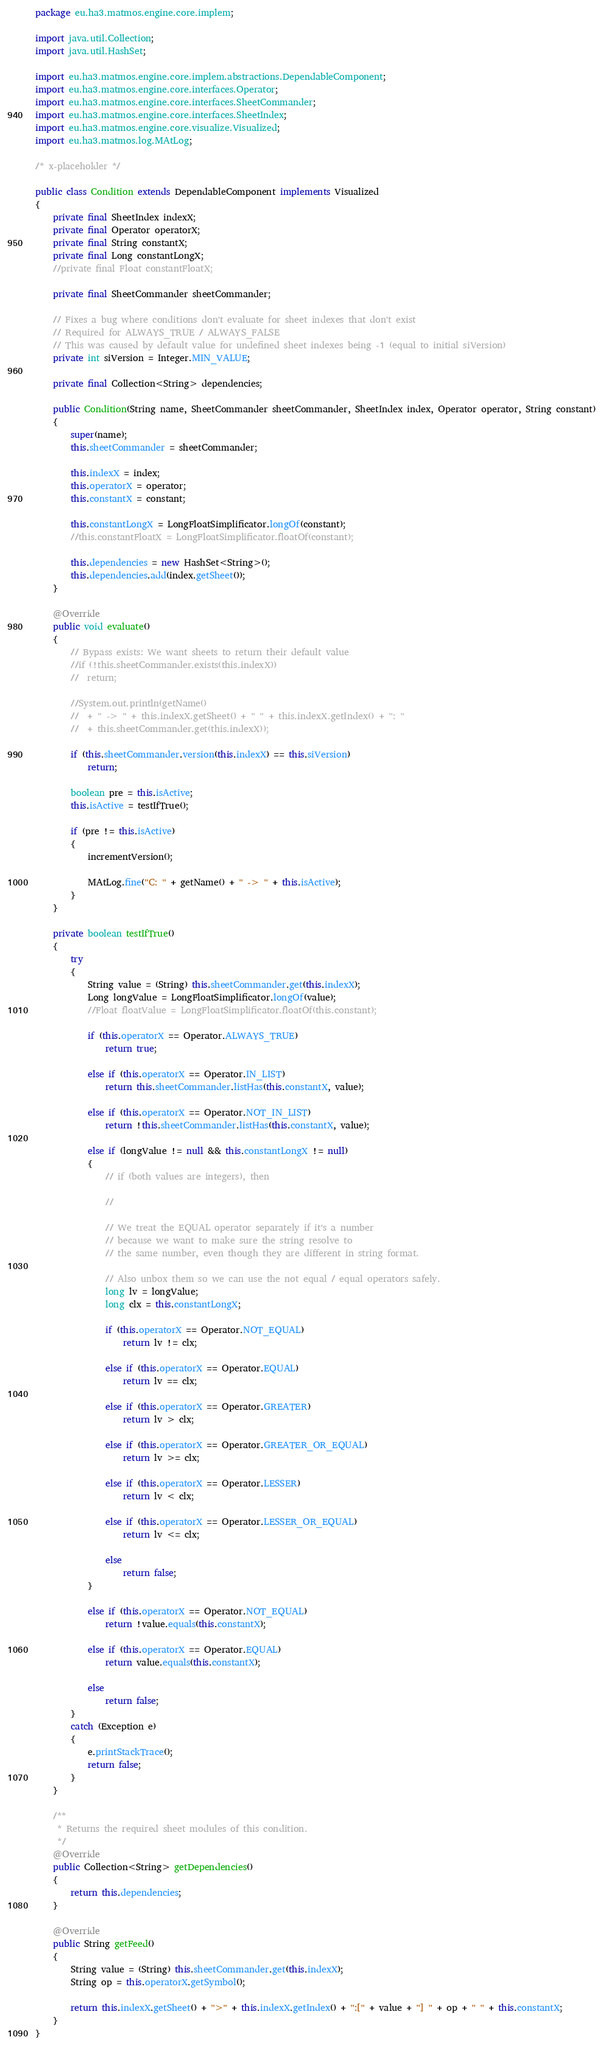<code> <loc_0><loc_0><loc_500><loc_500><_Java_>package eu.ha3.matmos.engine.core.implem;

import java.util.Collection;
import java.util.HashSet;

import eu.ha3.matmos.engine.core.implem.abstractions.DependableComponent;
import eu.ha3.matmos.engine.core.interfaces.Operator;
import eu.ha3.matmos.engine.core.interfaces.SheetCommander;
import eu.ha3.matmos.engine.core.interfaces.SheetIndex;
import eu.ha3.matmos.engine.core.visualize.Visualized;
import eu.ha3.matmos.log.MAtLog;

/* x-placeholder */

public class Condition extends DependableComponent implements Visualized
{
	private final SheetIndex indexX;
	private final Operator operatorX;
	private final String constantX;
	private final Long constantLongX;
	//private final Float constantFloatX;
	
	private final SheetCommander sheetCommander;
	
	// Fixes a bug where conditions don't evaluate for sheet indexes that don't exist
	// Required for ALWAYS_TRUE / ALWAYS_FALSE
	// This was caused by default value for undefined sheet indexes being -1 (equal to initial siVersion)
	private int siVersion = Integer.MIN_VALUE;
	
	private final Collection<String> dependencies;
	
	public Condition(String name, SheetCommander sheetCommander, SheetIndex index, Operator operator, String constant)
	{
		super(name);
		this.sheetCommander = sheetCommander;
		
		this.indexX = index;
		this.operatorX = operator;
		this.constantX = constant;
		
		this.constantLongX = LongFloatSimplificator.longOf(constant);
		//this.constantFloatX = LongFloatSimplificator.floatOf(constant);
		
		this.dependencies = new HashSet<String>();
		this.dependencies.add(index.getSheet());
	}
	
	@Override
	public void evaluate()
	{
		// Bypass exists: We want sheets to return their default value
		//if (!this.sheetCommander.exists(this.indexX))
		//	return;
		
		//System.out.println(getName()
		//	+ " -> " + this.indexX.getSheet() + " " + this.indexX.getIndex() + ": "
		//	+ this.sheetCommander.get(this.indexX));
		
		if (this.sheetCommander.version(this.indexX) == this.siVersion)
			return;
		
		boolean pre = this.isActive;
		this.isActive = testIfTrue();
		
		if (pre != this.isActive)
		{
			incrementVersion();
			
			MAtLog.fine("C: " + getName() + " -> " + this.isActive);
		}
	}
	
	private boolean testIfTrue()
	{
		try
		{
			String value = (String) this.sheetCommander.get(this.indexX);
			Long longValue = LongFloatSimplificator.longOf(value);
			//Float floatValue = LongFloatSimplificator.floatOf(this.constant);
			
			if (this.operatorX == Operator.ALWAYS_TRUE)
				return true;
			
			else if (this.operatorX == Operator.IN_LIST)
				return this.sheetCommander.listHas(this.constantX, value);
			
			else if (this.operatorX == Operator.NOT_IN_LIST)
				return !this.sheetCommander.listHas(this.constantX, value);
			
			else if (longValue != null && this.constantLongX != null)
			{
				// if (both values are integers), then
				
				//
				
				// We treat the EQUAL operator separately if it's a number
				// because we want to make sure the string resolve to
				// the same number, even though they are different in string format.
				
				// Also unbox them so we can use the not equal / equal operators safely.
				long lv = longValue;
				long clx = this.constantLongX;
				
				if (this.operatorX == Operator.NOT_EQUAL)
					return lv != clx;
				
				else if (this.operatorX == Operator.EQUAL)
					return lv == clx;
				
				else if (this.operatorX == Operator.GREATER)
					return lv > clx;
				
				else if (this.operatorX == Operator.GREATER_OR_EQUAL)
					return lv >= clx;
				
				else if (this.operatorX == Operator.LESSER)
					return lv < clx;
				
				else if (this.operatorX == Operator.LESSER_OR_EQUAL)
					return lv <= clx;
				
				else
					return false;
			}
			
			else if (this.operatorX == Operator.NOT_EQUAL)
				return !value.equals(this.constantX);
			
			else if (this.operatorX == Operator.EQUAL)
				return value.equals(this.constantX);
			
			else
				return false;
		}
		catch (Exception e)
		{
			e.printStackTrace();
			return false;
		}
	}
	
	/**
	 * Returns the required sheet modules of this condition.
	 */
	@Override
	public Collection<String> getDependencies()
	{
		return this.dependencies;
	}
	
	@Override
	public String getFeed()
	{
		String value = (String) this.sheetCommander.get(this.indexX);
		String op = this.operatorX.getSymbol();
		
		return this.indexX.getSheet() + ">" + this.indexX.getIndex() + ":[" + value + "] " + op + " " + this.constantX;
	}
}
</code> 